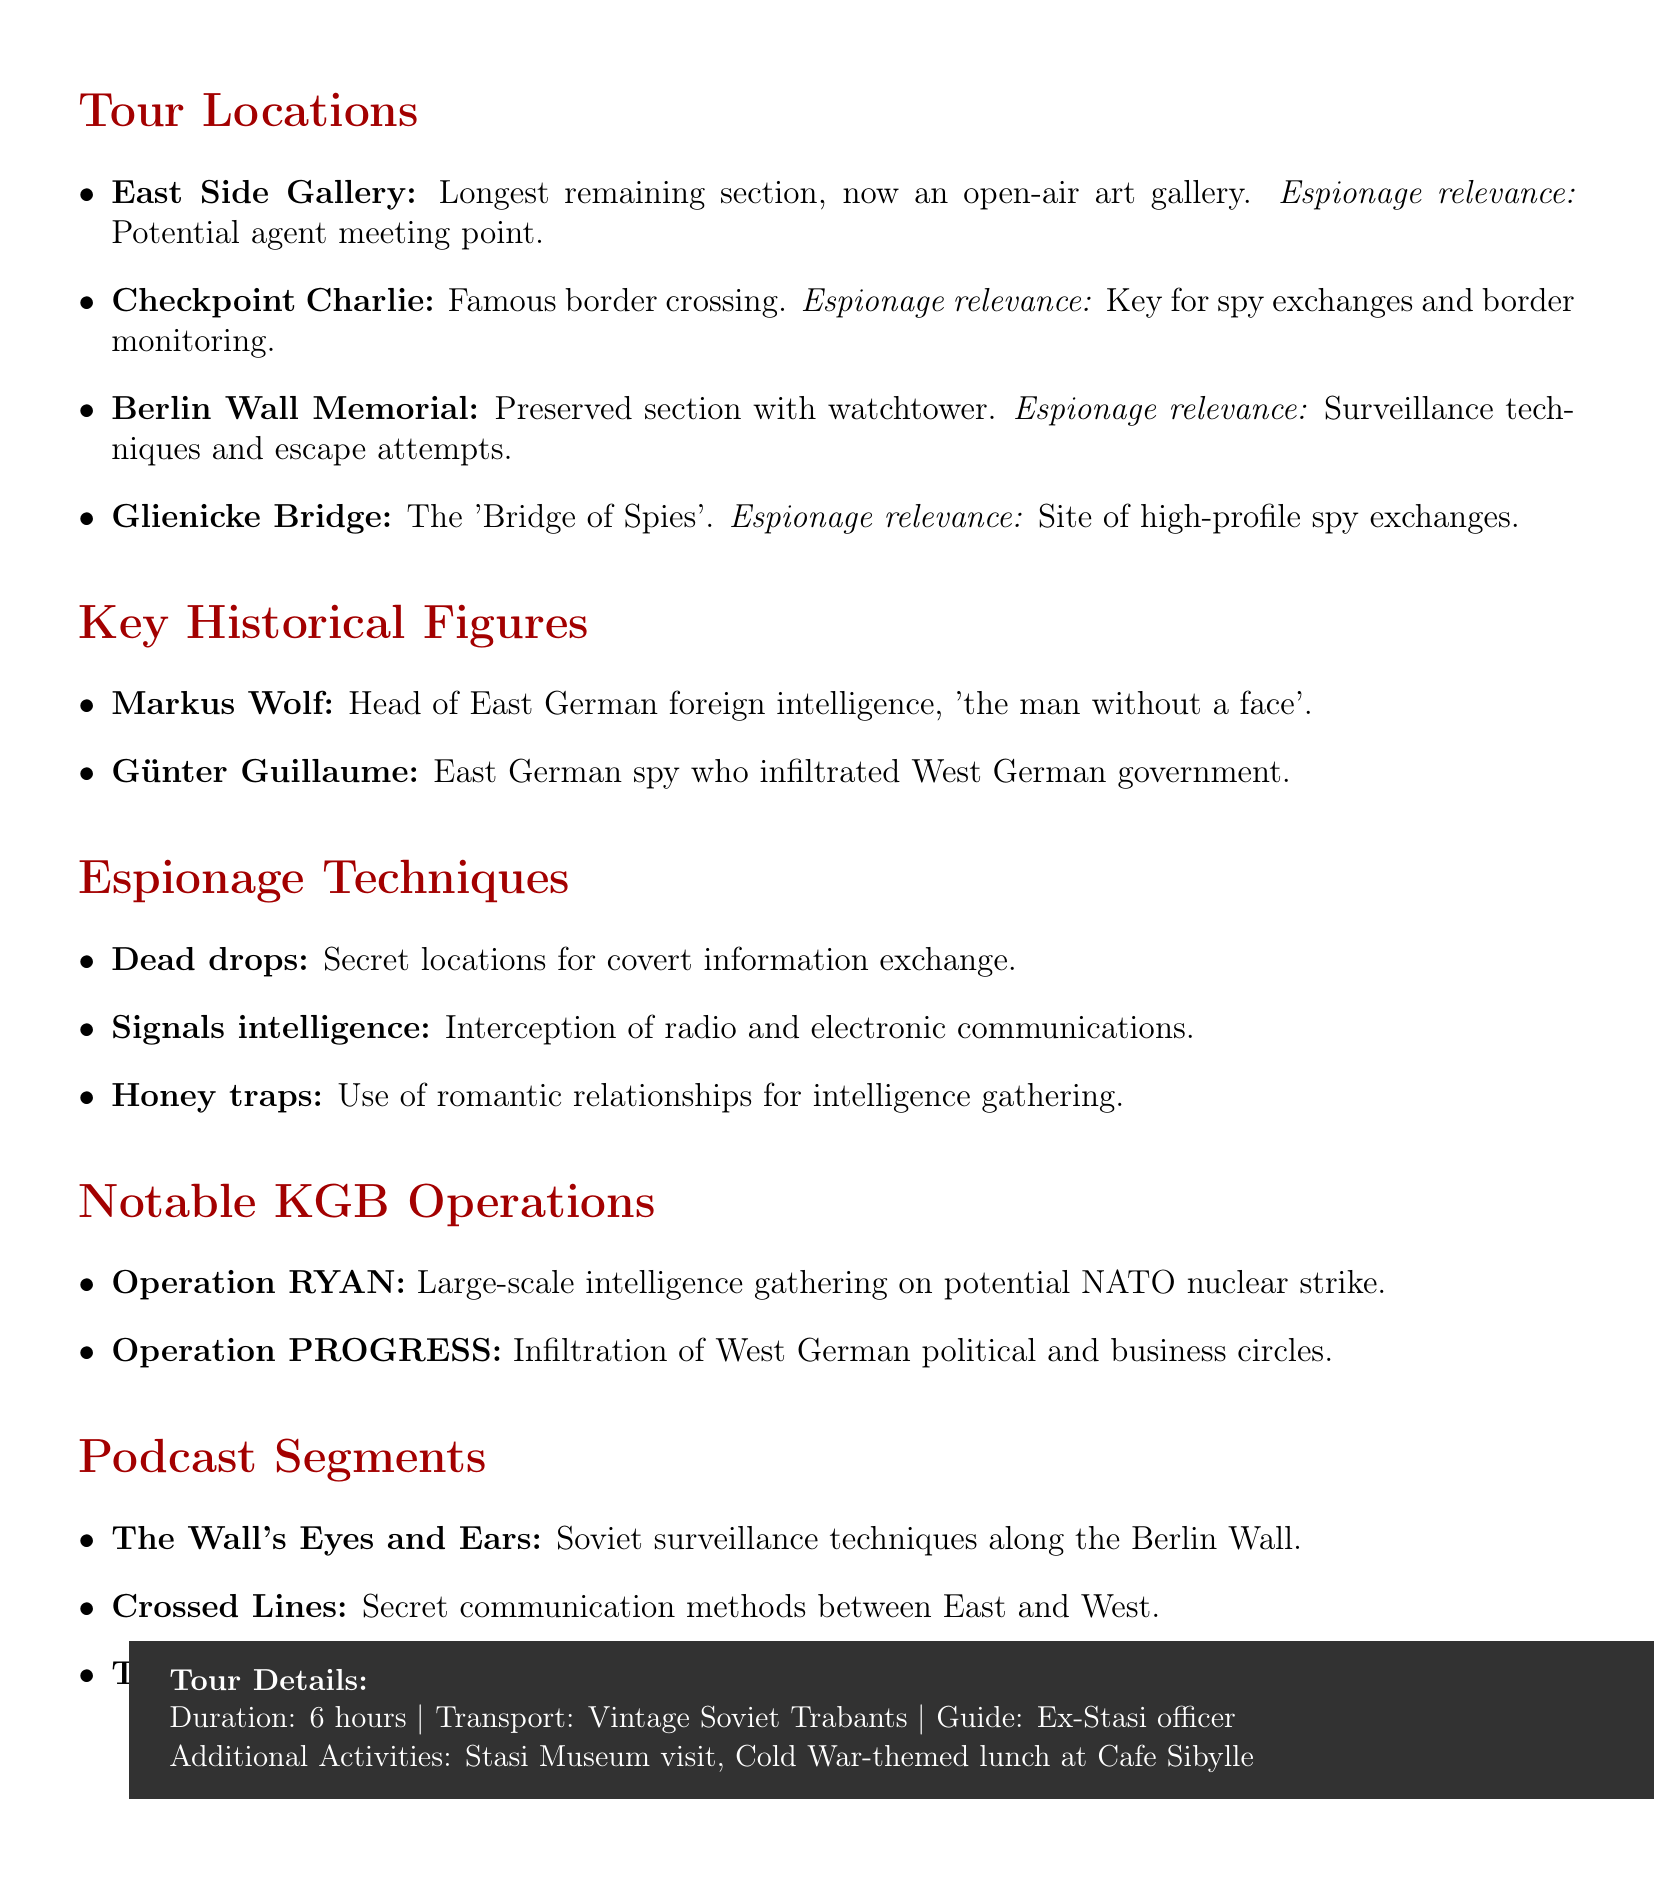What is the duration of the tour? The document states the tour duration is mentioned explicitly.
Answer: 6 hours What is the transportation mode for the tour? The document specifies the type of vehicle used for transporting participants.
Answer: Vintage Soviet-era Trabant cars Which historical figure is known as "the man without a face"? The document describes Markus Wolf with that particular phrase.
Answer: Markus Wolf What is the espionage relevance of East Side Gallery? The document provides a specific viewpoint about the significance of this location for espionage.
Answer: Potential meeting point for agents What is the focus of the podcast segment titled "Crossed Lines"? The document outlines the specific theme of this podcast segment.
Answer: Methods of secret communication between East and West How many notable KGB operations are mentioned? The document lists the KGB operations, which must be counted to answer.
Answer: 2 What two additional activities are included in the tour? The document specifies activities included in the tour package.
Answer: Visit to the Stasi Museum, Cold War-themed lunch at Cafe Sibylle What is the focus of "The Human Cost of Espionage" podcast segment? The document describes personal experiences related to espionage in this segment.
Answer: Personal stories of agents and their families during the Cold War 